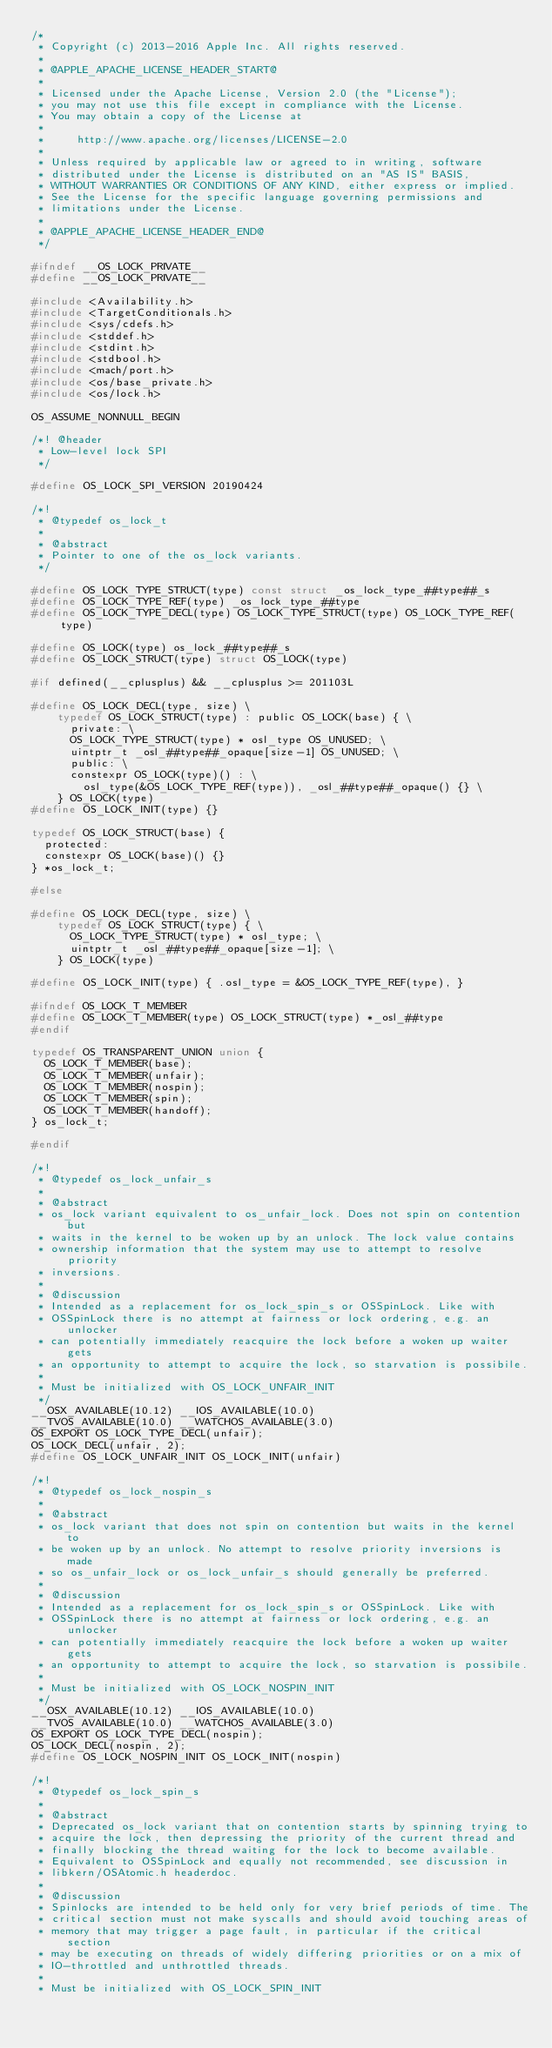<code> <loc_0><loc_0><loc_500><loc_500><_C_>/*
 * Copyright (c) 2013-2016 Apple Inc. All rights reserved.
 *
 * @APPLE_APACHE_LICENSE_HEADER_START@
 *
 * Licensed under the Apache License, Version 2.0 (the "License");
 * you may not use this file except in compliance with the License.
 * You may obtain a copy of the License at
 *
 *     http://www.apache.org/licenses/LICENSE-2.0
 *
 * Unless required by applicable law or agreed to in writing, software
 * distributed under the License is distributed on an "AS IS" BASIS,
 * WITHOUT WARRANTIES OR CONDITIONS OF ANY KIND, either express or implied.
 * See the License for the specific language governing permissions and
 * limitations under the License.
 *
 * @APPLE_APACHE_LICENSE_HEADER_END@
 */

#ifndef __OS_LOCK_PRIVATE__
#define __OS_LOCK_PRIVATE__

#include <Availability.h>
#include <TargetConditionals.h>
#include <sys/cdefs.h>
#include <stddef.h>
#include <stdint.h>
#include <stdbool.h>
#include <mach/port.h>
#include <os/base_private.h>
#include <os/lock.h>

OS_ASSUME_NONNULL_BEGIN

/*! @header
 * Low-level lock SPI
 */

#define OS_LOCK_SPI_VERSION 20190424

/*!
 * @typedef os_lock_t
 *
 * @abstract
 * Pointer to one of the os_lock variants.
 */

#define OS_LOCK_TYPE_STRUCT(type) const struct _os_lock_type_##type##_s
#define OS_LOCK_TYPE_REF(type) _os_lock_type_##type
#define OS_LOCK_TYPE_DECL(type) OS_LOCK_TYPE_STRUCT(type) OS_LOCK_TYPE_REF(type)

#define OS_LOCK(type) os_lock_##type##_s
#define OS_LOCK_STRUCT(type) struct OS_LOCK(type)

#if defined(__cplusplus) && __cplusplus >= 201103L

#define OS_LOCK_DECL(type, size) \
		typedef OS_LOCK_STRUCT(type) : public OS_LOCK(base) { \
			private: \
			OS_LOCK_TYPE_STRUCT(type) * osl_type OS_UNUSED; \
			uintptr_t _osl_##type##_opaque[size-1] OS_UNUSED; \
			public: \
			constexpr OS_LOCK(type)() : \
				osl_type(&OS_LOCK_TYPE_REF(type)), _osl_##type##_opaque() {} \
		} OS_LOCK(type)
#define OS_LOCK_INIT(type) {}

typedef OS_LOCK_STRUCT(base) {
	protected:
	constexpr OS_LOCK(base)() {}
} *os_lock_t;

#else

#define OS_LOCK_DECL(type, size) \
		typedef OS_LOCK_STRUCT(type) { \
			OS_LOCK_TYPE_STRUCT(type) * osl_type; \
			uintptr_t _osl_##type##_opaque[size-1]; \
		} OS_LOCK(type)

#define OS_LOCK_INIT(type) { .osl_type = &OS_LOCK_TYPE_REF(type), }

#ifndef OS_LOCK_T_MEMBER
#define OS_LOCK_T_MEMBER(type) OS_LOCK_STRUCT(type) *_osl_##type
#endif

typedef OS_TRANSPARENT_UNION union {
	OS_LOCK_T_MEMBER(base);
	OS_LOCK_T_MEMBER(unfair);
	OS_LOCK_T_MEMBER(nospin);
	OS_LOCK_T_MEMBER(spin);
	OS_LOCK_T_MEMBER(handoff);
} os_lock_t;

#endif

/*!
 * @typedef os_lock_unfair_s
 *
 * @abstract
 * os_lock variant equivalent to os_unfair_lock. Does not spin on contention but
 * waits in the kernel to be woken up by an unlock. The lock value contains
 * ownership information that the system may use to attempt to resolve priority
 * inversions.
 *
 * @discussion
 * Intended as a replacement for os_lock_spin_s or OSSpinLock. Like with
 * OSSpinLock there is no attempt at fairness or lock ordering, e.g. an unlocker
 * can potentially immediately reacquire the lock before a woken up waiter gets
 * an opportunity to attempt to acquire the lock, so starvation is possibile.
 *
 * Must be initialized with OS_LOCK_UNFAIR_INIT
 */
__OSX_AVAILABLE(10.12) __IOS_AVAILABLE(10.0)
__TVOS_AVAILABLE(10.0) __WATCHOS_AVAILABLE(3.0)
OS_EXPORT OS_LOCK_TYPE_DECL(unfair);
OS_LOCK_DECL(unfair, 2);
#define OS_LOCK_UNFAIR_INIT OS_LOCK_INIT(unfair)

/*!
 * @typedef os_lock_nospin_s
 *
 * @abstract
 * os_lock variant that does not spin on contention but waits in the kernel to
 * be woken up by an unlock. No attempt to resolve priority inversions is made
 * so os_unfair_lock or os_lock_unfair_s should generally be preferred.
 *
 * @discussion
 * Intended as a replacement for os_lock_spin_s or OSSpinLock. Like with
 * OSSpinLock there is no attempt at fairness or lock ordering, e.g. an unlocker
 * can potentially immediately reacquire the lock before a woken up waiter gets
 * an opportunity to attempt to acquire the lock, so starvation is possibile.
 *
 * Must be initialized with OS_LOCK_NOSPIN_INIT
 */
__OSX_AVAILABLE(10.12) __IOS_AVAILABLE(10.0)
__TVOS_AVAILABLE(10.0) __WATCHOS_AVAILABLE(3.0)
OS_EXPORT OS_LOCK_TYPE_DECL(nospin);
OS_LOCK_DECL(nospin, 2);
#define OS_LOCK_NOSPIN_INIT OS_LOCK_INIT(nospin)

/*!
 * @typedef os_lock_spin_s
 *
 * @abstract
 * Deprecated os_lock variant that on contention starts by spinning trying to
 * acquire the lock, then depressing the priority of the current thread and
 * finally blocking the thread waiting for the lock to become available.
 * Equivalent to OSSpinLock and equally not recommended, see discussion in
 * libkern/OSAtomic.h headerdoc.
 *
 * @discussion
 * Spinlocks are intended to be held only for very brief periods of time. The
 * critical section must not make syscalls and should avoid touching areas of
 * memory that may trigger a page fault, in particular if the critical section
 * may be executing on threads of widely differing priorities or on a mix of
 * IO-throttled and unthrottled threads.
 *
 * Must be initialized with OS_LOCK_SPIN_INIT</code> 